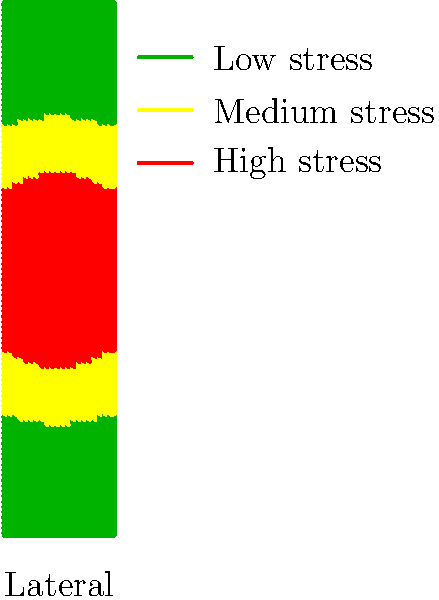Based on the color-coded stress distribution diagram of a prosthetic limb, which area experiences the highest stress concentration, and how might this information influence national policy decisions on prosthetic research and development funding? 1. Analyze the stress distribution:
   - Green areas indicate low stress
   - Yellow areas indicate medium stress
   - Red areas indicate high stress

2. Identify the highest stress concentration:
   - The red area in the center of the prosthetic limb indicates the highest stress

3. Interpret the stress distribution:
   - Stress is concentrated in the middle of the limb
   - Stress decreases towards the edges

4. Consider policy implications:
   - High-stress areas are prone to failure and may require more frequent replacement
   - Research funding could be directed towards:
     a) Developing materials that can better withstand stress in the central area
     b) Designing prosthetics that distribute stress more evenly
     c) Improving manufacturing techniques to reinforce high-stress areas

5. Potential policy decisions:
   - Allocate more funding for research into advanced materials for prosthetics
   - Implement quality standards for prosthetic limbs based on stress distribution
   - Develop guidelines for prosthetic design that emphasize stress management
   - Create incentives for companies to innovate in prosthetic stress reduction

6. Long-term benefits:
   - Improved durability of prosthetic limbs
   - Reduced healthcare costs associated with prosthetic replacements
   - Enhanced quality of life for prosthetic users
   - Potential for economic growth in the prosthetic industry
Answer: Central area; fund research for stress-resistant materials and improved designs 